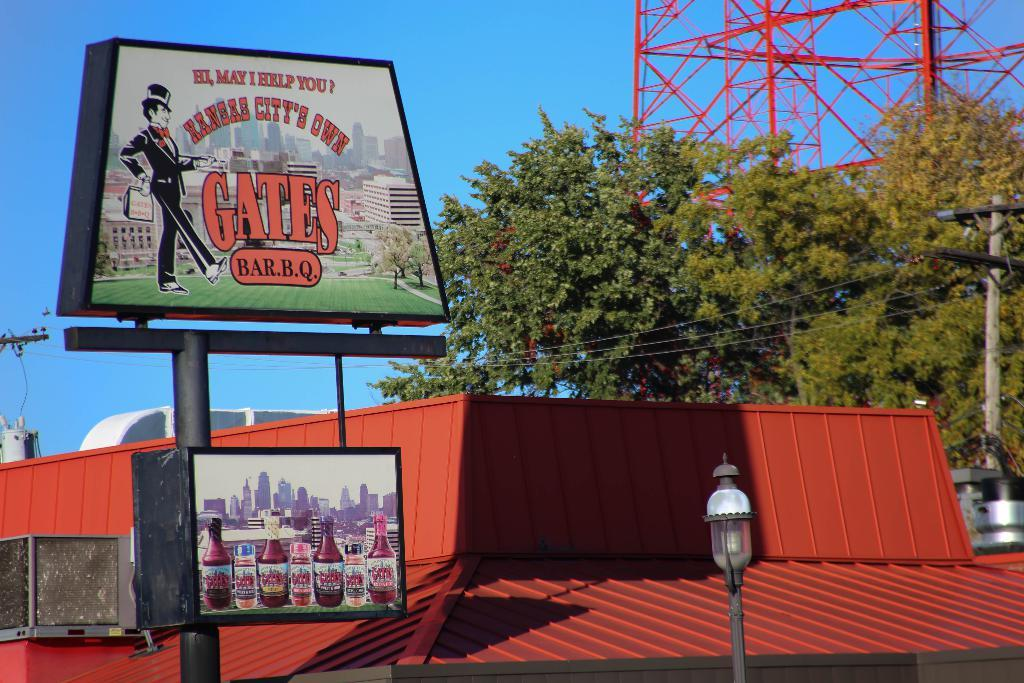<image>
Relay a brief, clear account of the picture shown. A tall sign above advertises Gates BBQ with a figure in a tux. 